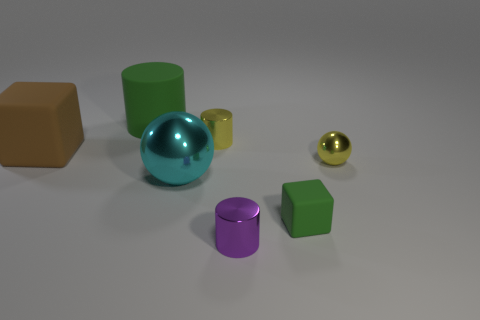Subtract 1 cylinders. How many cylinders are left? 2 Subtract all metal cylinders. How many cylinders are left? 1 Add 1 tiny green matte objects. How many objects exist? 8 Subtract all yellow cylinders. How many cylinders are left? 2 Add 1 cylinders. How many cylinders are left? 4 Add 1 large purple things. How many large purple things exist? 1 Subtract 1 green blocks. How many objects are left? 6 Subtract all cylinders. How many objects are left? 4 Subtract all blue cylinders. Subtract all red blocks. How many cylinders are left? 3 Subtract all red matte cylinders. Subtract all big cyan things. How many objects are left? 6 